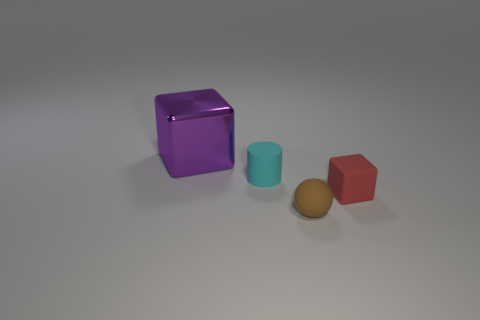Are there any other things that have the same size as the purple thing?
Offer a very short reply. No. Is there any other thing that has the same material as the purple object?
Offer a very short reply. No. How many things are either blocks that are behind the cyan rubber thing or small matte things behind the small matte ball?
Make the answer very short. 3. There is a small object behind the block that is right of the small sphere; what shape is it?
Offer a very short reply. Cylinder. Are there any tiny cyan cylinders made of the same material as the tiny cyan thing?
Offer a very short reply. No. What is the color of the tiny thing that is the same shape as the large purple shiny thing?
Make the answer very short. Red. Are there fewer small objects right of the cyan thing than objects in front of the big purple cube?
Your answer should be compact. Yes. What number of other things are there of the same shape as the cyan thing?
Keep it short and to the point. 0. Is the number of purple shiny things that are on the right side of the large purple metallic object less than the number of yellow matte cylinders?
Give a very brief answer. No. There is a small thing that is behind the rubber cube; what material is it?
Give a very brief answer. Rubber. 